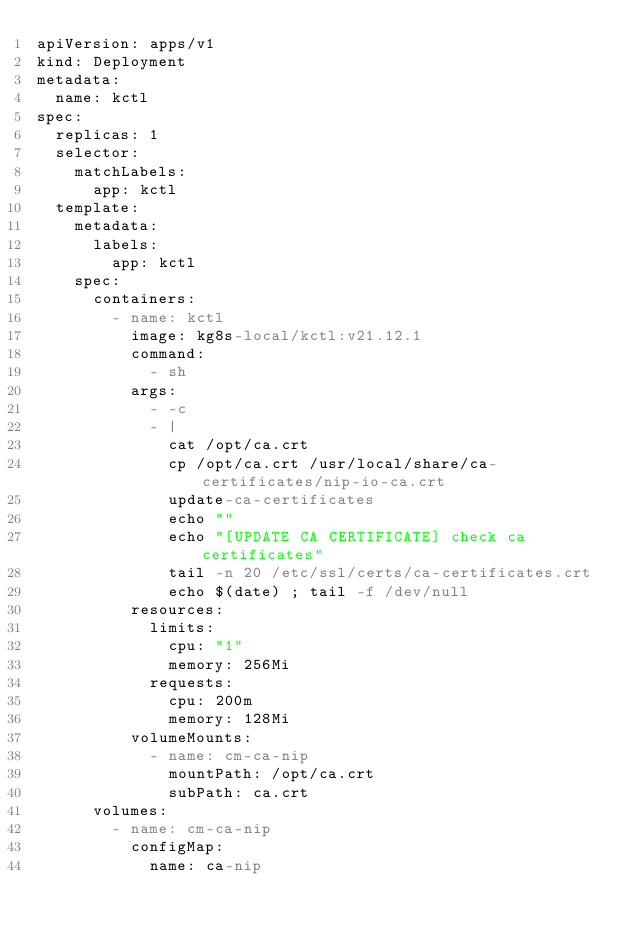Convert code to text. <code><loc_0><loc_0><loc_500><loc_500><_YAML_>apiVersion: apps/v1
kind: Deployment
metadata:
  name: kctl
spec:
  replicas: 1
  selector:
    matchLabels:
      app: kctl
  template:
    metadata:
      labels:
        app: kctl
    spec:
      containers:
        - name: kctl
          image: kg8s-local/kctl:v21.12.1
          command:
            - sh
          args:
            - -c
            - |
              cat /opt/ca.crt
              cp /opt/ca.crt /usr/local/share/ca-certificates/nip-io-ca.crt
              update-ca-certificates
              echo ""
              echo "[UPDATE CA CERTIFICATE] check ca certificates"
              tail -n 20 /etc/ssl/certs/ca-certificates.crt
              echo $(date) ; tail -f /dev/null
          resources:
            limits:
              cpu: "1"
              memory: 256Mi
            requests:
              cpu: 200m
              memory: 128Mi
          volumeMounts:
            - name: cm-ca-nip
              mountPath: /opt/ca.crt
              subPath: ca.crt
      volumes:
        - name: cm-ca-nip
          configMap:
            name: ca-nip
</code> 